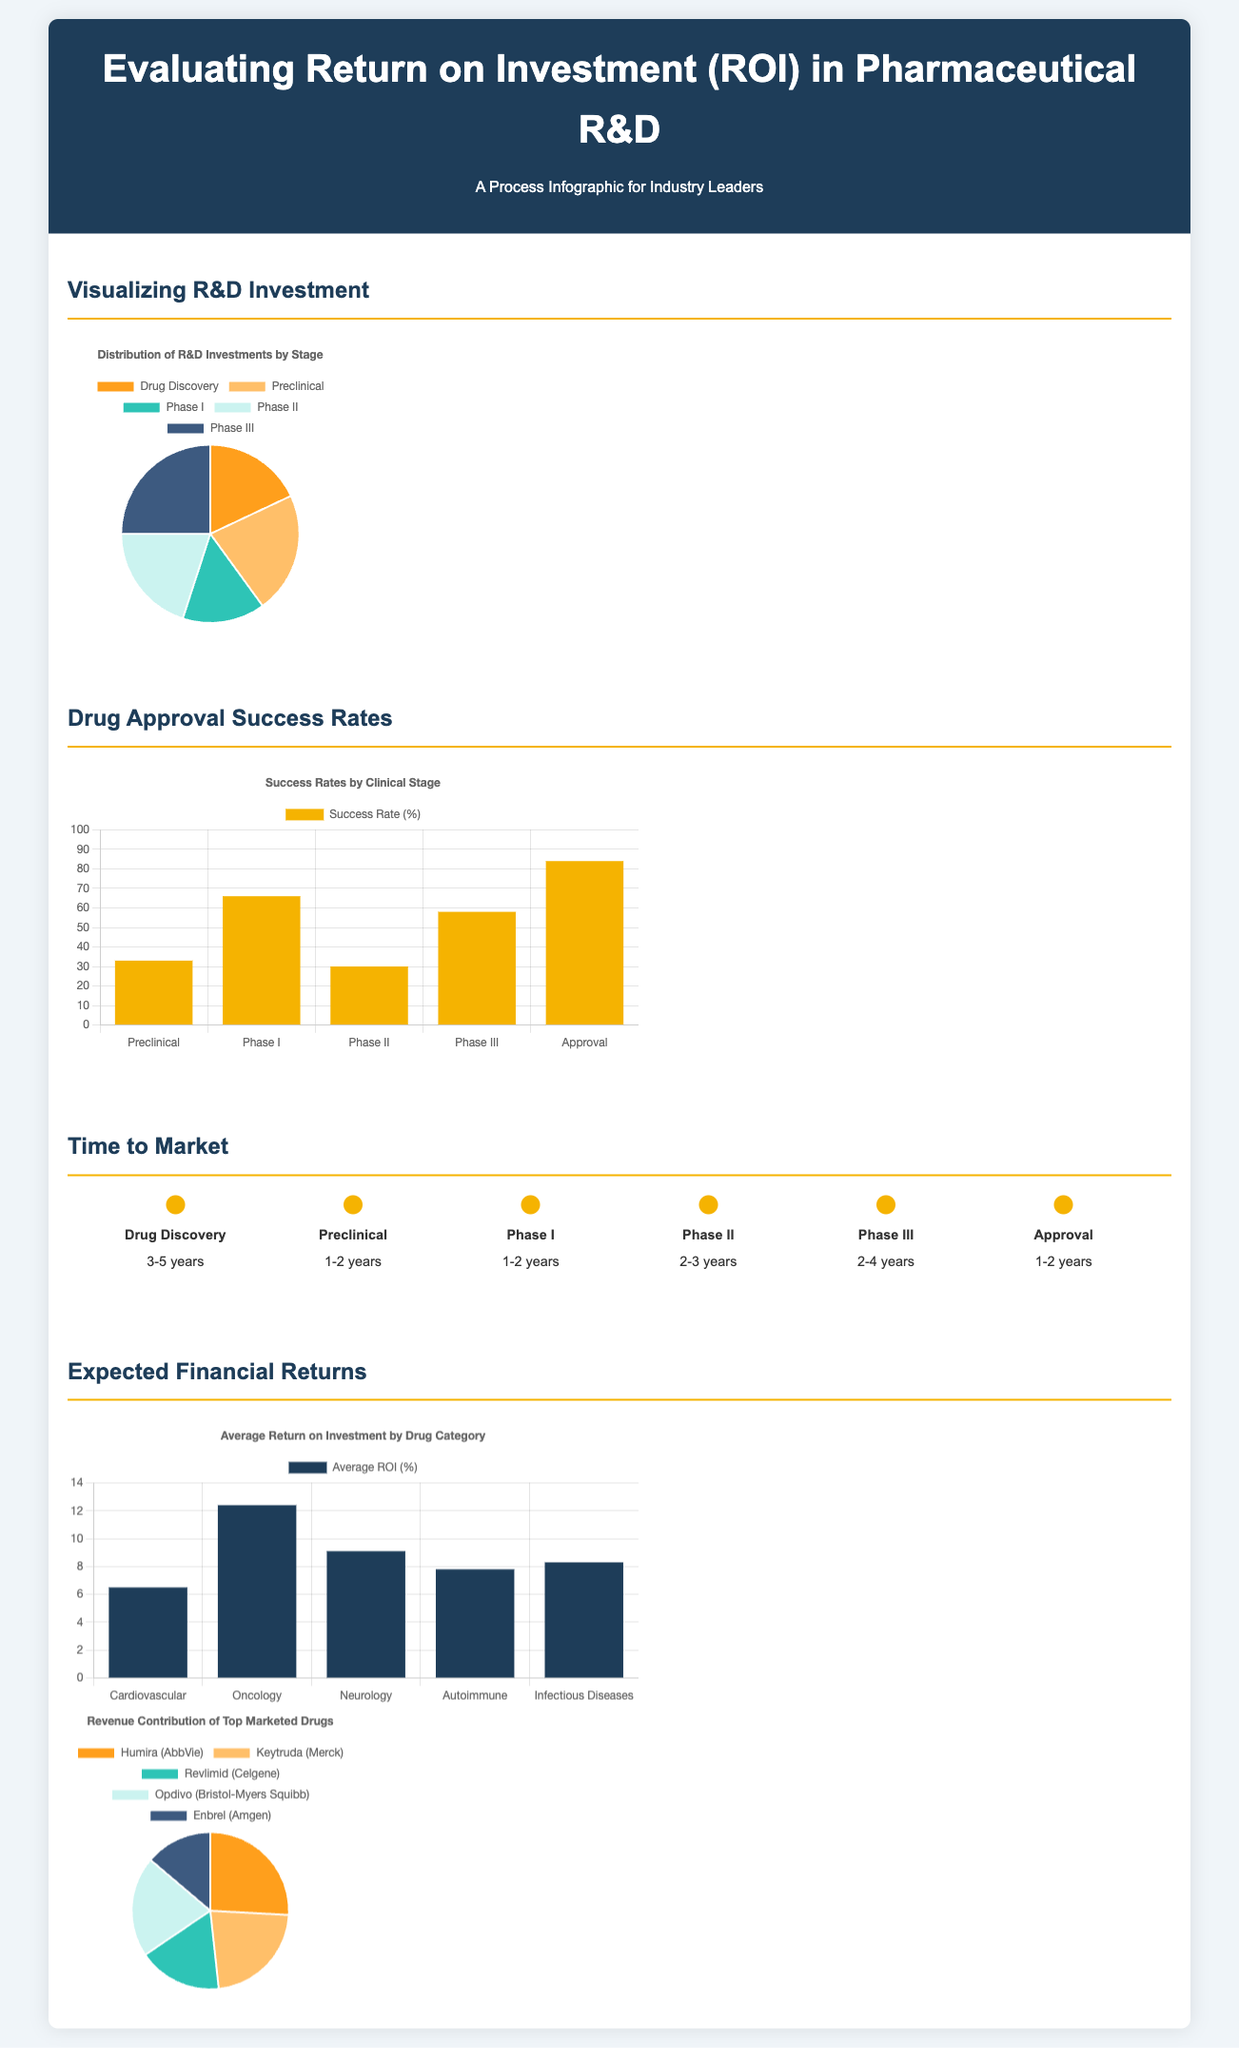What is the percentage for Phase II success rate? The Phase II success rate is 30%, as shown in the success rates bar chart in the document.
Answer: 30 What stage has the highest R&D investment percentage? The drug approval process indicates that Phase III has the highest R&D investment at 25%.
Answer: Phase III How long does Drug Discovery typically take? The timeline in the document states that Drug Discovery usually takes 3-5 years.
Answer: 3-5 years Which drug category has the highest average ROI? In the ROI chart, Oncology is depicted as having the highest average ROI at 12.4%.
Answer: Oncology What is the total time from Drug Discovery to Approval? By adding the time estimates for each phase from the timeline, the total time is approximately 9 to 16 years.
Answer: 9-16 years What is the average ROI for Autoimmune drugs? The document specifies that the average ROI for Autoimmune drugs is 7.8%.
Answer: 7.8 How many drugs are listed in the Revenue Contribution chart? The revenue contribution pie chart lists a total of 5 marketed drugs.
Answer: 5 What is the success rate for Approval? According to the success rates chart, the success rate for Approval is 84%.
Answer: 84 What color represents the Preclinical stage in the R&D Investment chart? The Preclinical stage is represented by the color yellow in the investment pie chart.
Answer: Yellow 